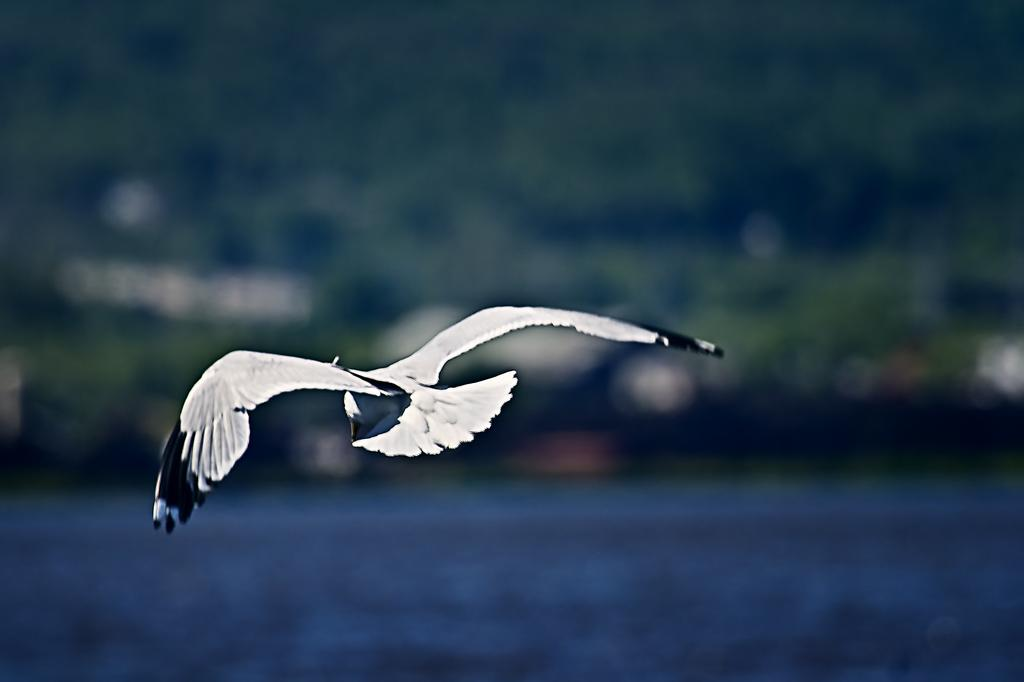What is the main subject of the image? There is a bird flying in the air in the image. What can be seen at the bottom of the image? There is water visible at the bottom of the image. What type of natural environment is visible in the background of the image? There are trees in the background of the image. Can you describe the lighting conditions in the image? The image may have been taken in the evening, suggesting a dimmer light source. What type of stone can be seen on the bridge in the image? There is no stone or bridge present in the image; it features a bird flying over water with trees in the background. 